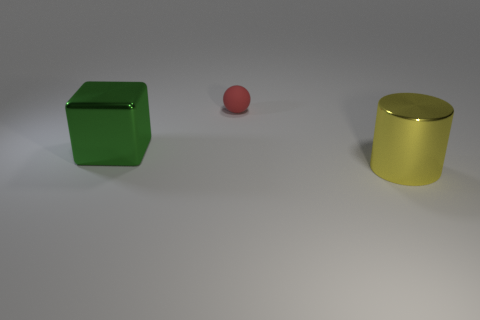Add 1 small cyan rubber things. How many objects exist? 4 Subtract all cylinders. How many objects are left? 2 Add 3 metal cubes. How many metal cubes are left? 4 Add 1 large blue matte cylinders. How many large blue matte cylinders exist? 1 Subtract 0 cyan cylinders. How many objects are left? 3 Subtract all big shiny cylinders. Subtract all large shiny blocks. How many objects are left? 1 